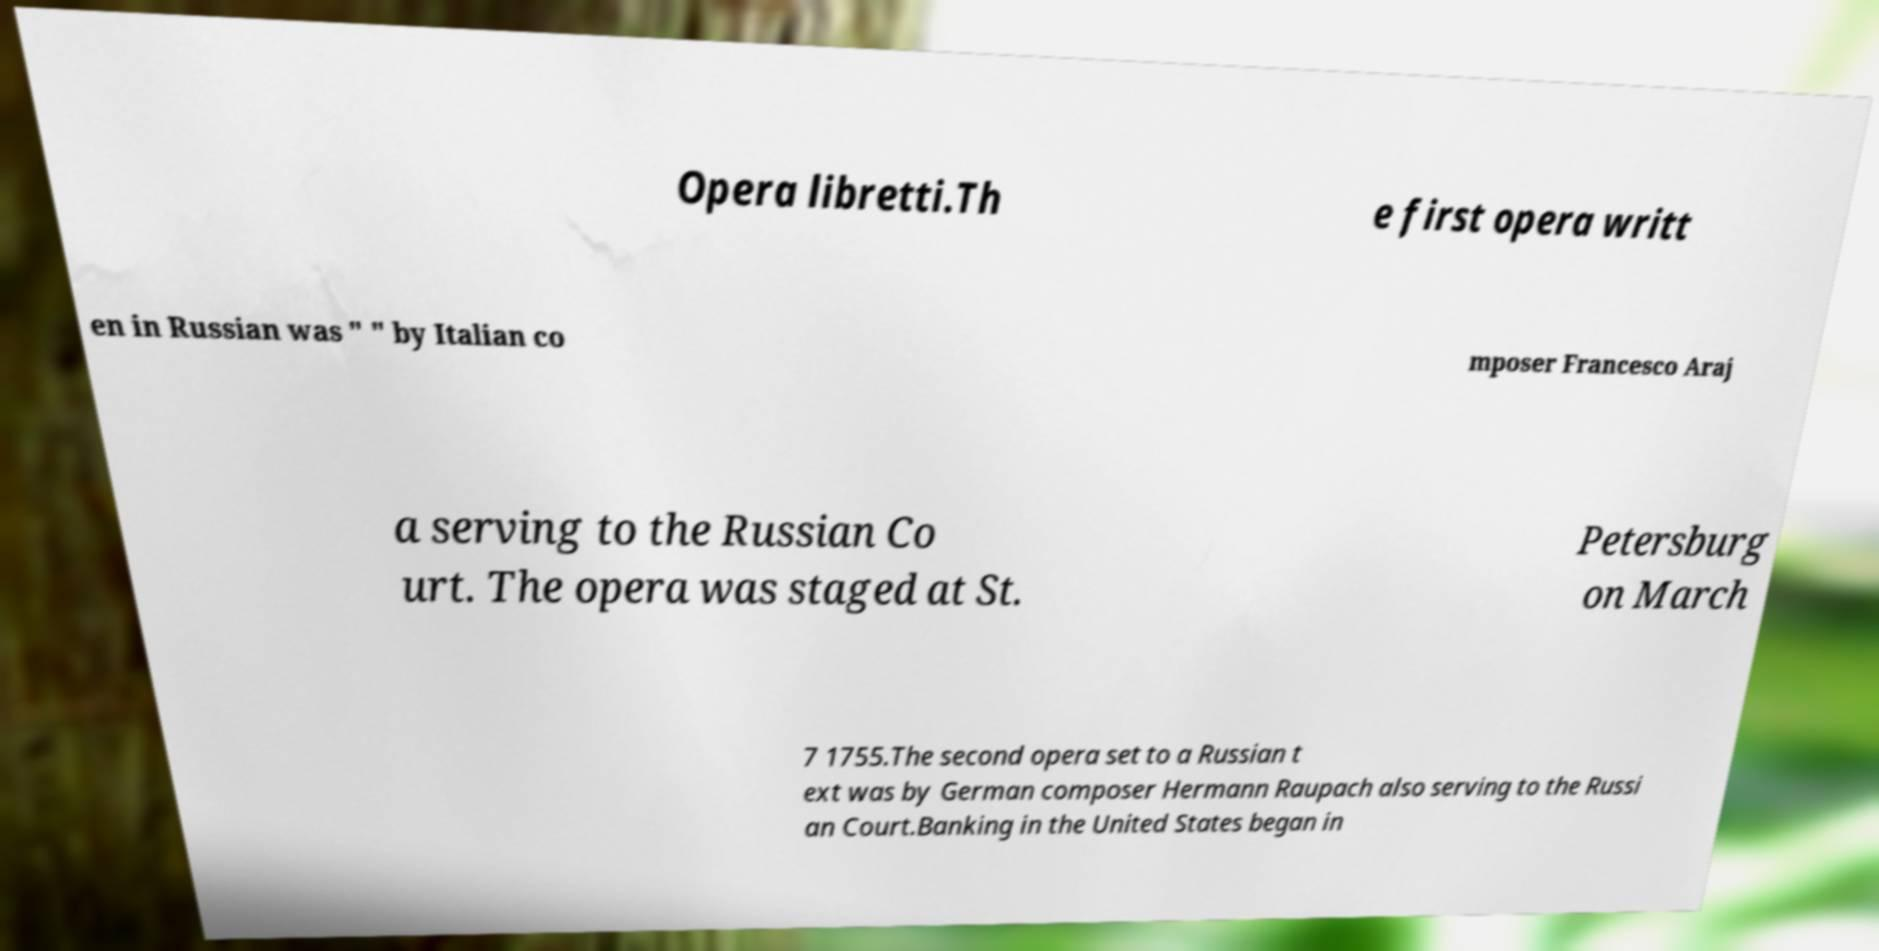Can you accurately transcribe the text from the provided image for me? Opera libretti.Th e first opera writt en in Russian was " " by Italian co mposer Francesco Araj a serving to the Russian Co urt. The opera was staged at St. Petersburg on March 7 1755.The second opera set to a Russian t ext was by German composer Hermann Raupach also serving to the Russi an Court.Banking in the United States began in 